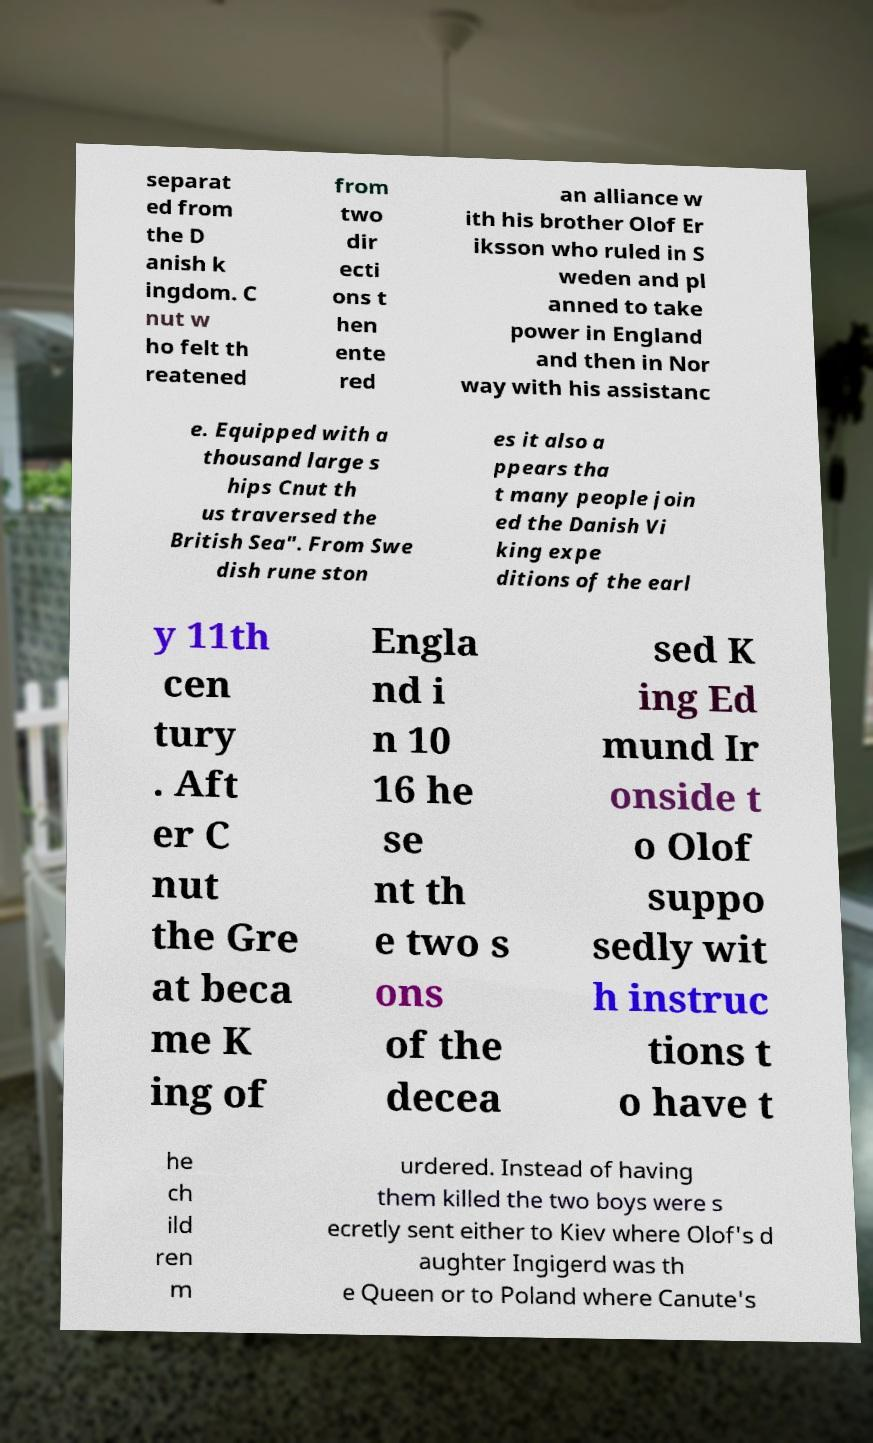I need the written content from this picture converted into text. Can you do that? separat ed from the D anish k ingdom. C nut w ho felt th reatened from two dir ecti ons t hen ente red an alliance w ith his brother Olof Er iksson who ruled in S weden and pl anned to take power in England and then in Nor way with his assistanc e. Equipped with a thousand large s hips Cnut th us traversed the British Sea". From Swe dish rune ston es it also a ppears tha t many people join ed the Danish Vi king expe ditions of the earl y 11th cen tury . Aft er C nut the Gre at beca me K ing of Engla nd i n 10 16 he se nt th e two s ons of the decea sed K ing Ed mund Ir onside t o Olof suppo sedly wit h instruc tions t o have t he ch ild ren m urdered. Instead of having them killed the two boys were s ecretly sent either to Kiev where Olof's d aughter Ingigerd was th e Queen or to Poland where Canute's 